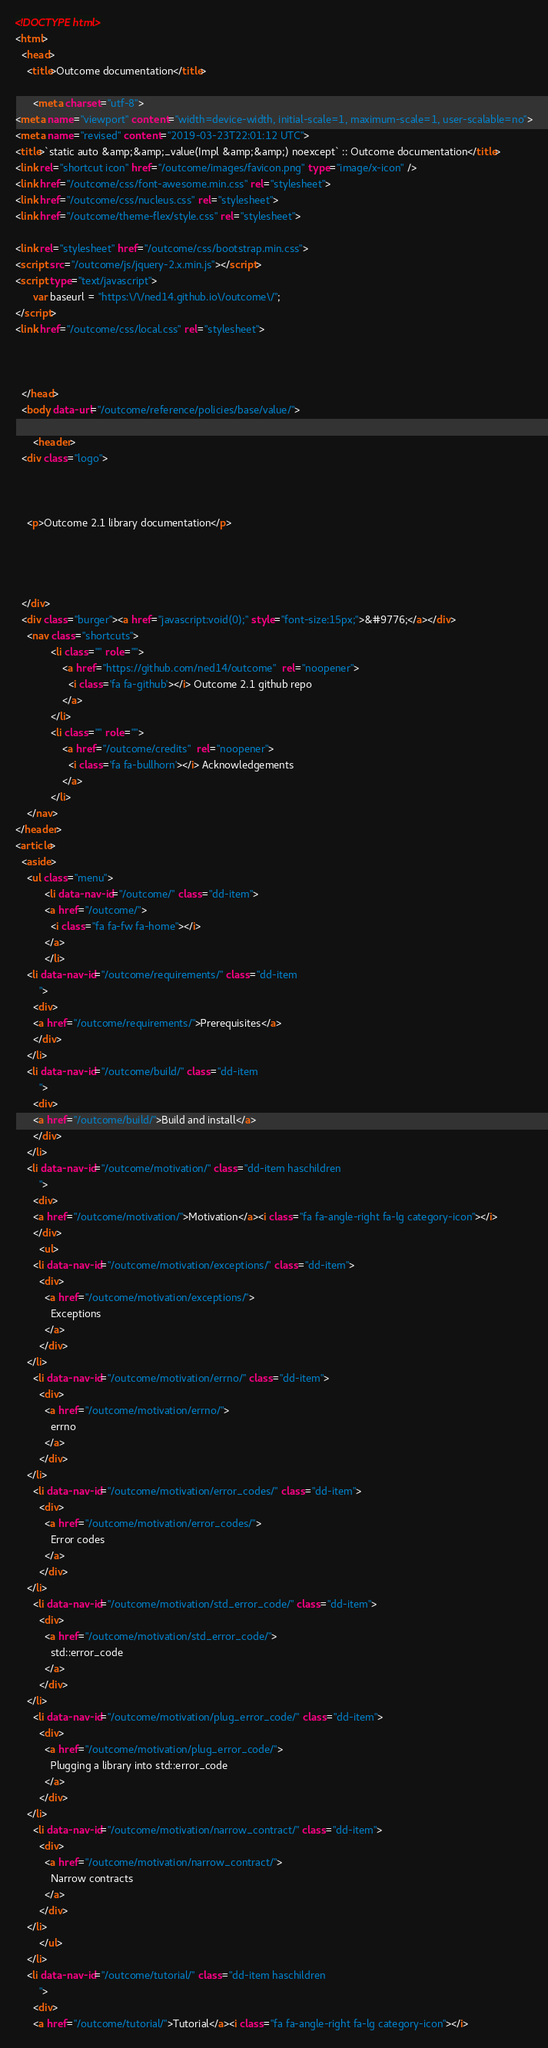<code> <loc_0><loc_0><loc_500><loc_500><_HTML_><!DOCTYPE html>
<html>
  <head>
    <title>Outcome documentation</title>
    
      <meta charset="utf-8">
<meta name="viewport" content="width=device-width, initial-scale=1, maximum-scale=1, user-scalable=no">
<meta name="revised" content="2019-03-23T22:01:12 UTC">
<title>`static auto &amp;&amp;_value(Impl &amp;&amp;) noexcept` :: Outcome documentation</title>
<link rel="shortcut icon" href="/outcome/images/favicon.png" type="image/x-icon" />
<link href="/outcome/css/font-awesome.min.css" rel="stylesheet">
<link href="/outcome/css/nucleus.css" rel="stylesheet">
<link href="/outcome/theme-flex/style.css" rel="stylesheet">

<link rel="stylesheet" href="/outcome/css/bootstrap.min.css">
<script src="/outcome/js/jquery-2.x.min.js"></script>
<script type="text/javascript">
      var baseurl = "https:\/\/ned14.github.io\/outcome\/";
</script>
<link href="/outcome/css/local.css" rel="stylesheet">


    
  </head>
  <body data-url="/outcome/reference/policies/base/value/">
    
      <header>
  <div class="logo">
    
	
  
    <p>Outcome 2.1 library documentation</p>

  


  </div>
  <div class="burger"><a href="javascript:void(0);" style="font-size:15px;">&#9776;</a></div>
    <nav class="shortcuts">
            <li class="" role="">
                <a href="https://github.com/ned14/outcome"  rel="noopener">
                  <i class='fa fa-github'></i> Outcome 2.1 github repo
                </a>
            </li>
            <li class="" role="">
                <a href="/outcome/credits"  rel="noopener">
                  <i class='fa fa-bullhorn'></i> Acknowledgements
                </a>
            </li>
    </nav>
</header>
<article>
  <aside>
    <ul class="menu">
          <li data-nav-id="/outcome/" class="dd-item">
          <a href="/outcome/">
            <i class="fa fa-fw fa-home"></i>
          </a>
          </li>
    <li data-nav-id="/outcome/requirements/" class="dd-item
        ">
      <div>
      <a href="/outcome/requirements/">Prerequisites</a>
      </div>
    </li>
    <li data-nav-id="/outcome/build/" class="dd-item
        ">
      <div>
      <a href="/outcome/build/">Build and install</a>
      </div>
    </li>
    <li data-nav-id="/outcome/motivation/" class="dd-item haschildren
        ">
      <div>
      <a href="/outcome/motivation/">Motivation</a><i class="fa fa-angle-right fa-lg category-icon"></i>
      </div>
        <ul>
      <li data-nav-id="/outcome/motivation/exceptions/" class="dd-item">
        <div>
          <a href="/outcome/motivation/exceptions/">
            Exceptions
          </a>
        </div>
    </li>
      <li data-nav-id="/outcome/motivation/errno/" class="dd-item">
        <div>
          <a href="/outcome/motivation/errno/">
            errno
          </a>
        </div>
    </li>
      <li data-nav-id="/outcome/motivation/error_codes/" class="dd-item">
        <div>
          <a href="/outcome/motivation/error_codes/">
            Error codes
          </a>
        </div>
    </li>
      <li data-nav-id="/outcome/motivation/std_error_code/" class="dd-item">
        <div>
          <a href="/outcome/motivation/std_error_code/">
            std::error_code
          </a>
        </div>
    </li>
      <li data-nav-id="/outcome/motivation/plug_error_code/" class="dd-item">
        <div>
          <a href="/outcome/motivation/plug_error_code/">
            Plugging a library into std::error_code
          </a>
        </div>
    </li>
      <li data-nav-id="/outcome/motivation/narrow_contract/" class="dd-item">
        <div>
          <a href="/outcome/motivation/narrow_contract/">
            Narrow contracts
          </a>
        </div>
    </li>
        </ul>
    </li>
    <li data-nav-id="/outcome/tutorial/" class="dd-item haschildren
        ">
      <div>
      <a href="/outcome/tutorial/">Tutorial</a><i class="fa fa-angle-right fa-lg category-icon"></i></code> 